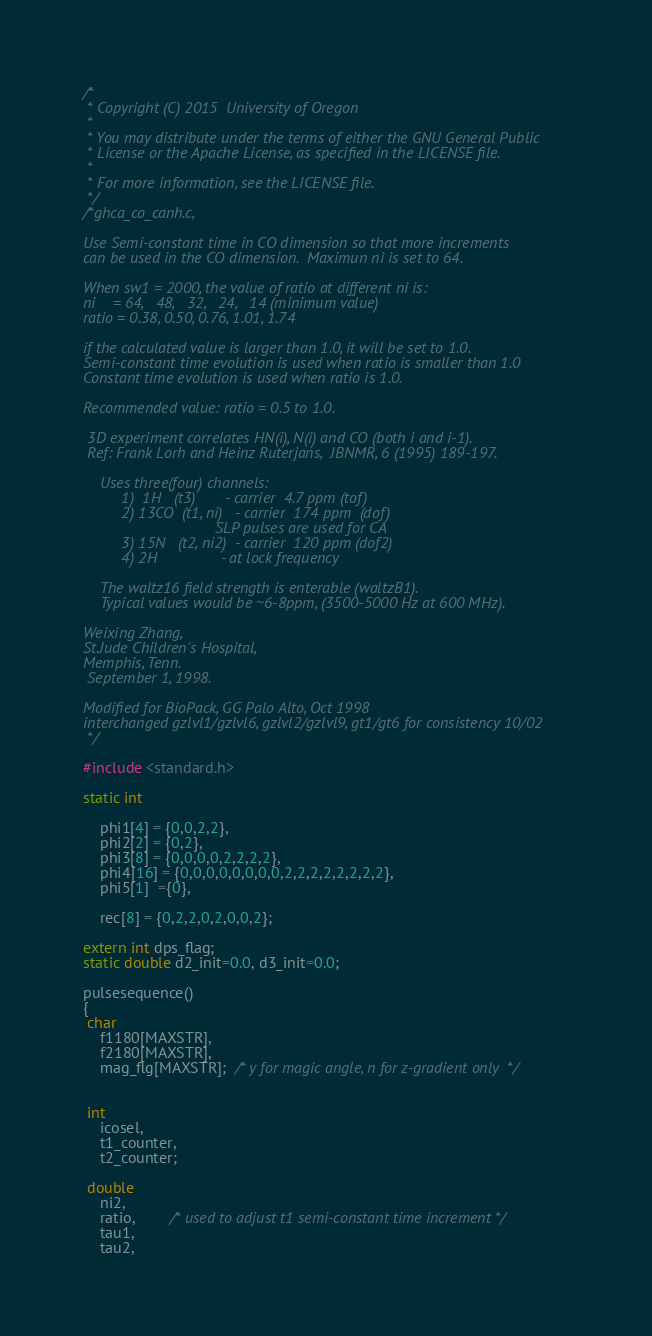Convert code to text. <code><loc_0><loc_0><loc_500><loc_500><_C_>/*
 * Copyright (C) 2015  University of Oregon
 *
 * You may distribute under the terms of either the GNU General Public
 * License or the Apache License, as specified in the LICENSE file.
 *
 * For more information, see the LICENSE file.
 */
/*ghca_co_canh.c, 

Use Semi-constant time in CO dimension so that more increments
can be used in the CO dimension.  Maximun ni is set to 64.

When sw1 = 2000, the value of ratio at different ni is:
ni    = 64,   48,   32,   24,   14 (minimum value)
ratio = 0.38, 0.50, 0.76, 1.01, 1.74

if the calculated value is larger than 1.0, it will be set to 1.0.
Semi-constant time evolution is used when ratio is smaller than 1.0
Constant time evolution is used when ratio is 1.0.

Recommended value: ratio = 0.5 to 1.0.

 3D experiment correlates HN(i), N(i) and CO (both i and i-1).
 Ref: Frank Lorh and Heinz Ruterjans,  JBNMR, 6 (1995) 189-197.

    Uses three(four) channels:
         1)  1H   (t3)       - carrier  4.7 ppm (tof)
         2) 13CO  (t1, ni)   - carrier  174 ppm  (dof)
                               SLP pulses are used for CA
         3) 15N   (t2, ni2)  - carrier  120 ppm (dof2) 
         4) 2H               - at lock frequency

    The waltz16 field strength is enterable (waltzB1).
    Typical values would be ~6-8ppm, (3500-5000 Hz at 600 MHz).
  
Weixing Zhang,
St.Jude Children's Hospital,
Memphis, Tenn.
 September 1, 1998.

Modified for BioPack, GG Palo Alto, Oct 1998
interchanged gzlvl1/gzlvl6, gzlvl2/gzlvl9, gt1/gt6 for consistency 10/02
 */

#include <standard.h> 

static int      
    
    phi1[4] = {0,0,2,2},
    phi2[2] = {0,2},   
    phi3[8] = {0,0,0,0,2,2,2,2},
    phi4[16] = {0,0,0,0,0,0,0,0,2,2,2,2,2,2,2,2},
    phi5[1]  ={0},
                
    rec[8] = {0,2,2,0,2,0,0,2};

extern int dps_flag;       
static double d2_init=0.0, d3_init=0.0;
            
pulsesequence()
{
 char    
    f1180[MAXSTR],    
    f2180[MAXSTR],
    mag_flg[MAXSTR];  /* y for magic angle, n for z-gradient only  */


 int        
    icosel,
    t1_counter,   
    t2_counter;   

 double      
    ni2,  
    ratio,        /* used to adjust t1 semi-constant time increment */
    tau1,       
    tau2,       </code> 